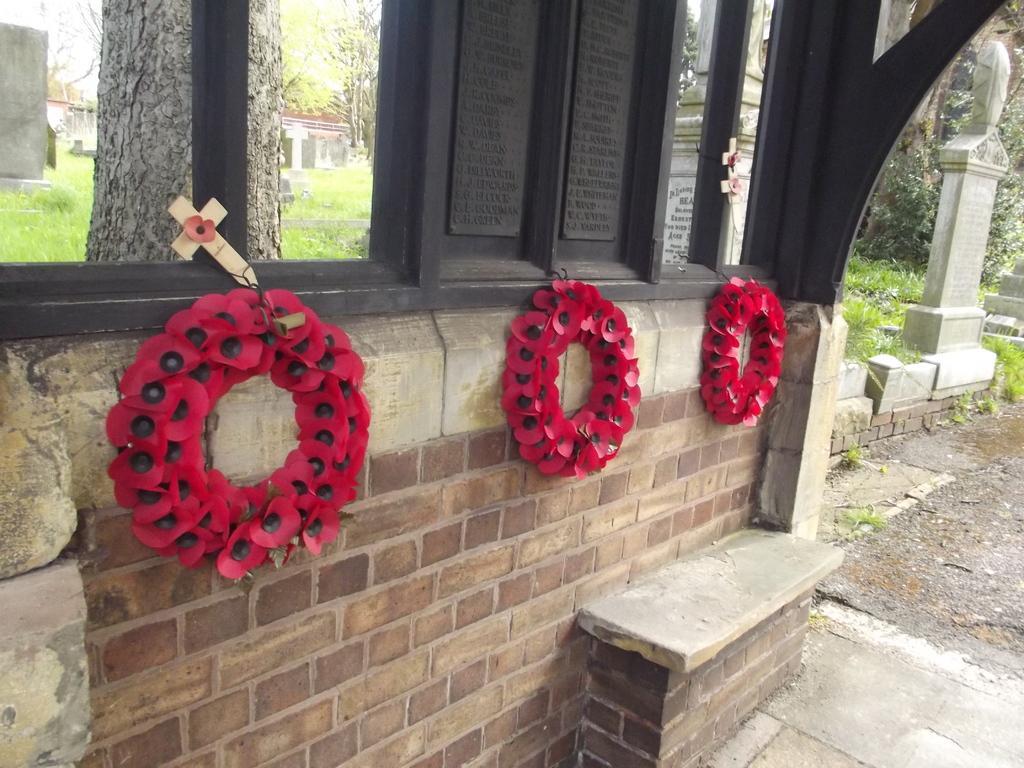In one or two sentences, can you explain what this image depicts? In this image we can see some wreaths and the cross hanged to a wall. On the right side we can see some memorials. On the backside we can see the bark of a tree, grass, a house with a roof, a group of trees and the sky. 